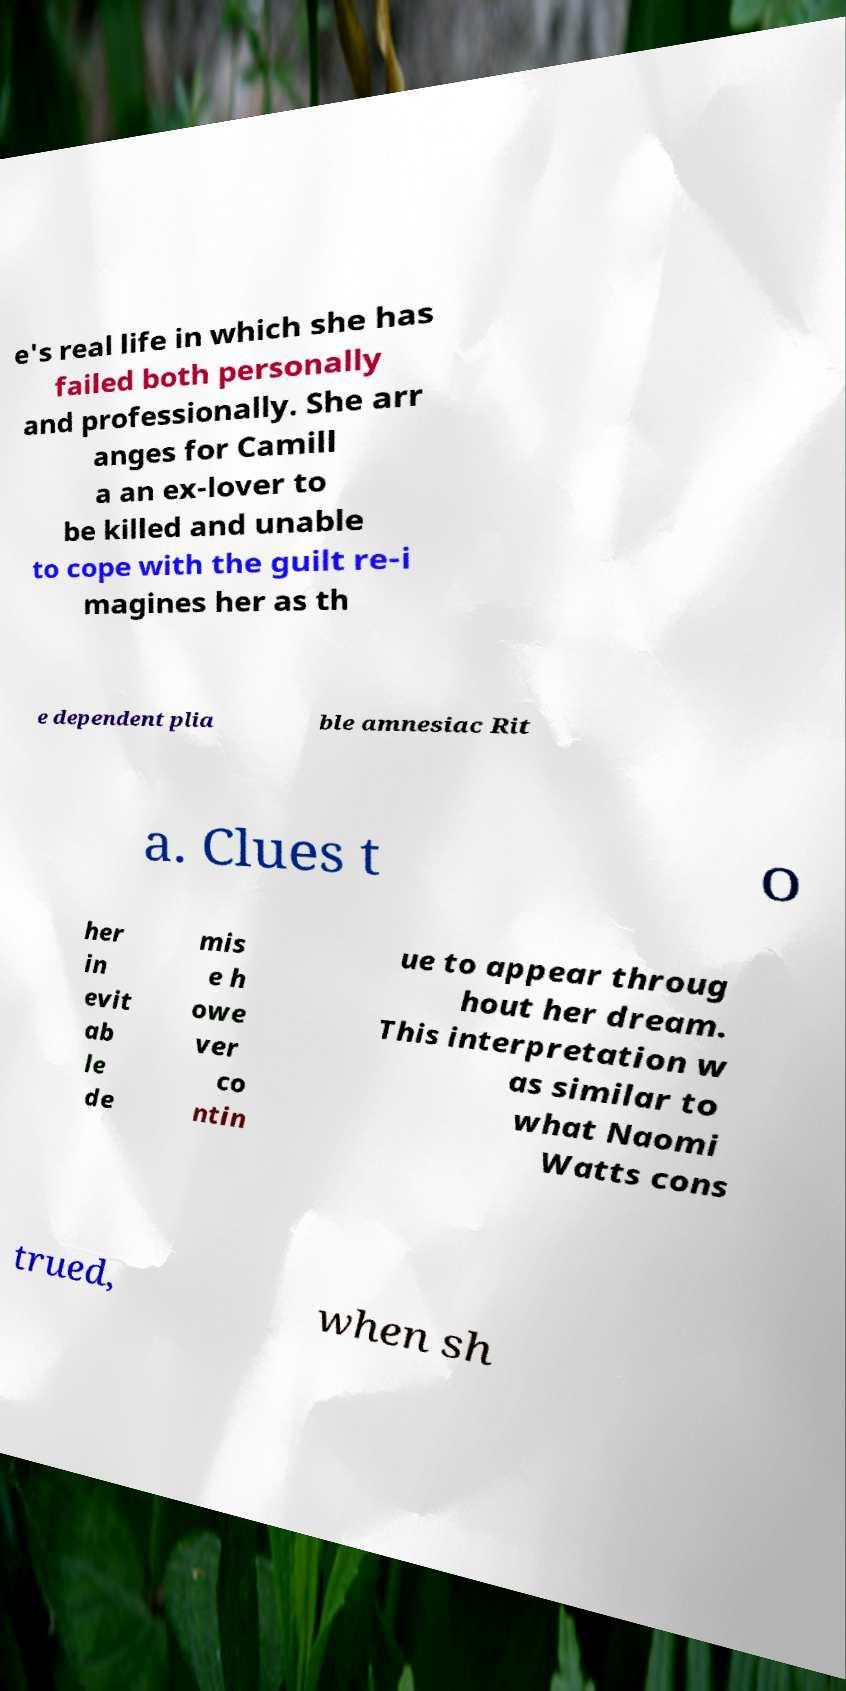Please identify and transcribe the text found in this image. e's real life in which she has failed both personally and professionally. She arr anges for Camill a an ex-lover to be killed and unable to cope with the guilt re-i magines her as th e dependent plia ble amnesiac Rit a. Clues t o her in evit ab le de mis e h owe ver co ntin ue to appear throug hout her dream. This interpretation w as similar to what Naomi Watts cons trued, when sh 